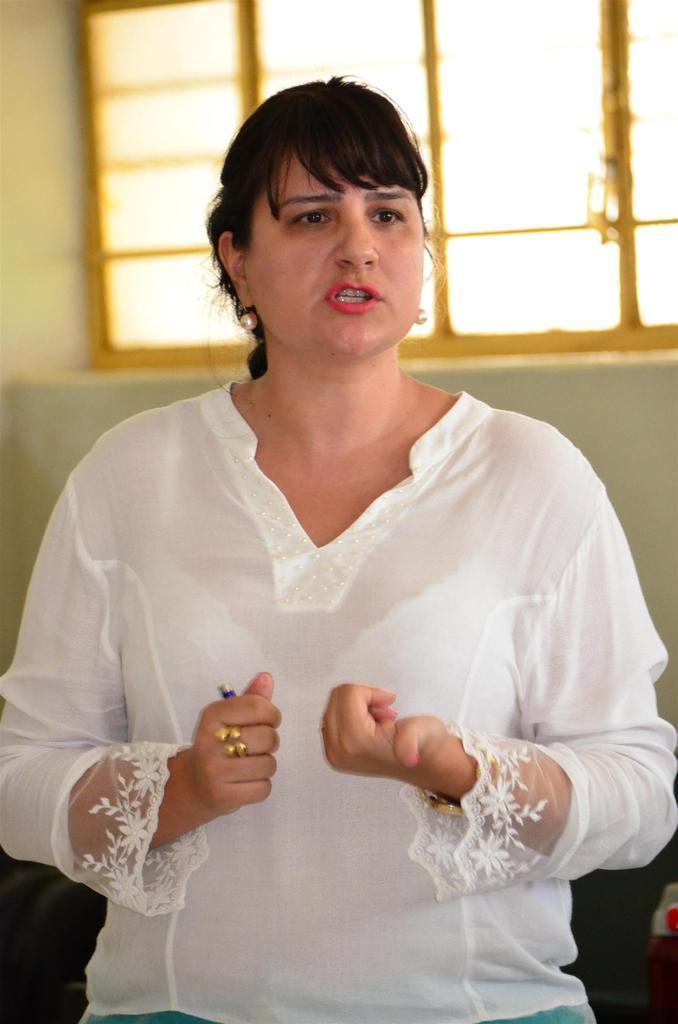How would you summarize this image in a sentence or two? In the foreground of this picture, there is a woman in white dress and she is talking something and in the background, there is a wall and a window. 